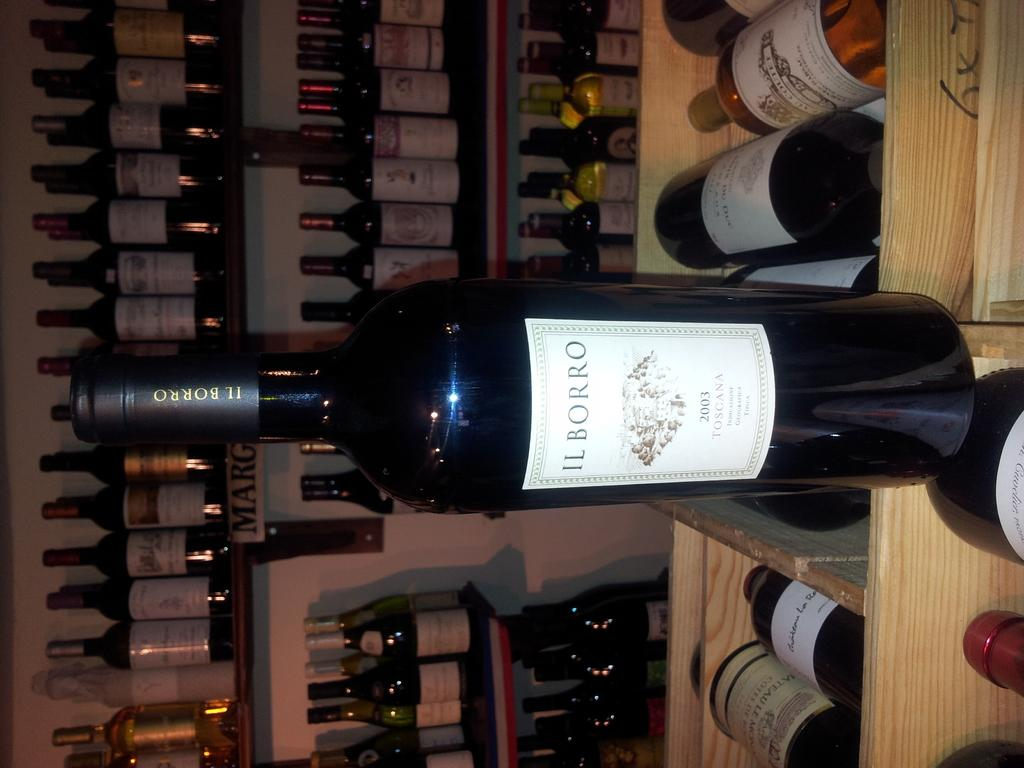<image>
Offer a succinct explanation of the picture presented. A bottle of wine labelled IL BORRO sitting on top of other wine bottles. 